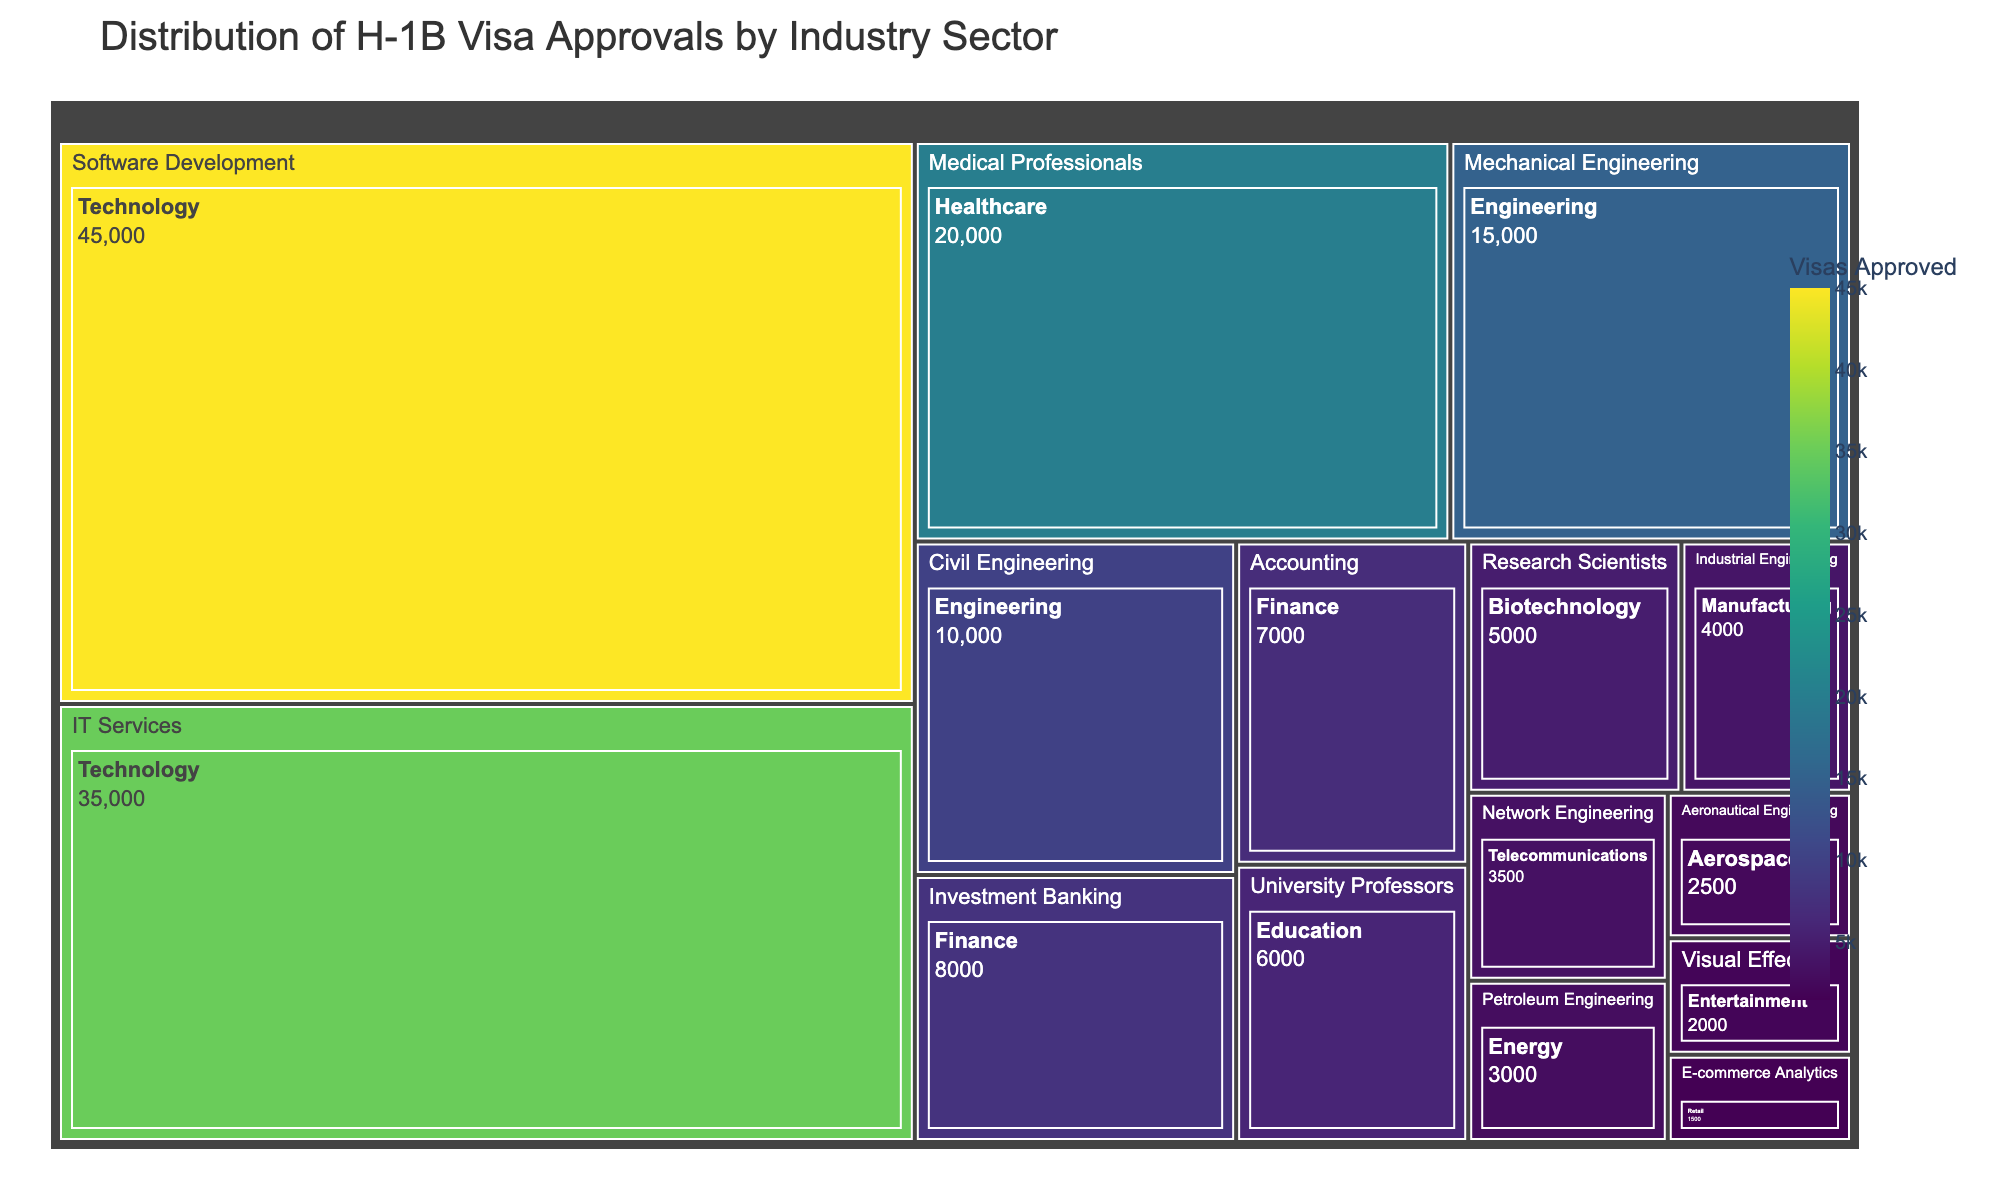What is the title of the treemap? The title of the treemap is visible at the top of the figure.
Answer: Distribution of H-1B Visa Approvals by Industry Sector Which industry sector has the highest number of H-1B visa approvals? The sector with the largest area in the treemap represents the highest number of H-1B visa approvals.
Answer: Software Development How many H-1B visas were approved in the Finance sector? Locate the Finance sector on the treemap and sum the values for Investment Banking and Accounting.
Answer: 15,000 What is the total number of H-1B visas approved in both Healthcare and Education sectors combined? Add the number of approved visas for Medical Professionals in Healthcare and University Professors in Education.
Answer: 26,000 Compare the number of H-1B visa approvals between Technology and Biotechnology sectors. Which one has more, and by how much? Sum the values for Software Development and IT Services under Technology, and compare this with the value for Research Scientists under Biotechnology.
Answer: Technology has 75,000 more approvals Which sector in the Engineering industry has the least number of H-1B visa approvals? Look at the smaller areas within the Engineering industry.
Answer: Civil Engineering How does the number of H-1B visa approvals in the Energy sector compare with those in the Aerospace sector? Compare the values for Petroleum Engineering (Energy) and Aeronautical Engineering (Aerospace).
Answer: Energy has 500 more approvals What percentage of total H-1B visas is approved for Software Development alone? Divide the approvals for Software Development by the total number of approvals and multiply by 100.
Answer: 34.88% What is the combined total of H-1B visas approved for Manufacturing and Telecommunications sectors? Add the number of approved visas for Industrial Engineering in Manufacturing and Network Engineering in Telecommunications.
Answer: 7,500 If you combine all sectors in the Finance and Energy industries, how many H-1B visas were approved in total? Sum the values for Investment Banking and Accounting in Finance, and Petroleum Engineering in Energy.
Answer: 18,000 